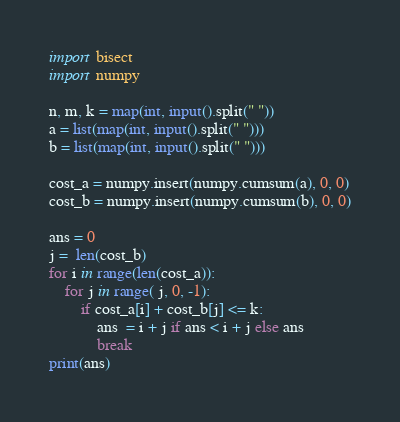Convert code to text. <code><loc_0><loc_0><loc_500><loc_500><_Python_>
import bisect
import numpy

n, m, k = map(int, input().split(" "))
a = list(map(int, input().split(" ")))
b = list(map(int, input().split(" ")))

cost_a = numpy.insert(numpy.cumsum(a), 0, 0)
cost_b = numpy.insert(numpy.cumsum(b), 0, 0)

ans = 0
j =  len(cost_b)
for i in range(len(cost_a)):
    for j in range( j, 0, -1):
        if cost_a[i] + cost_b[j] <= k:
            ans  = i + j if ans < i + j else ans
            break
print(ans)</code> 